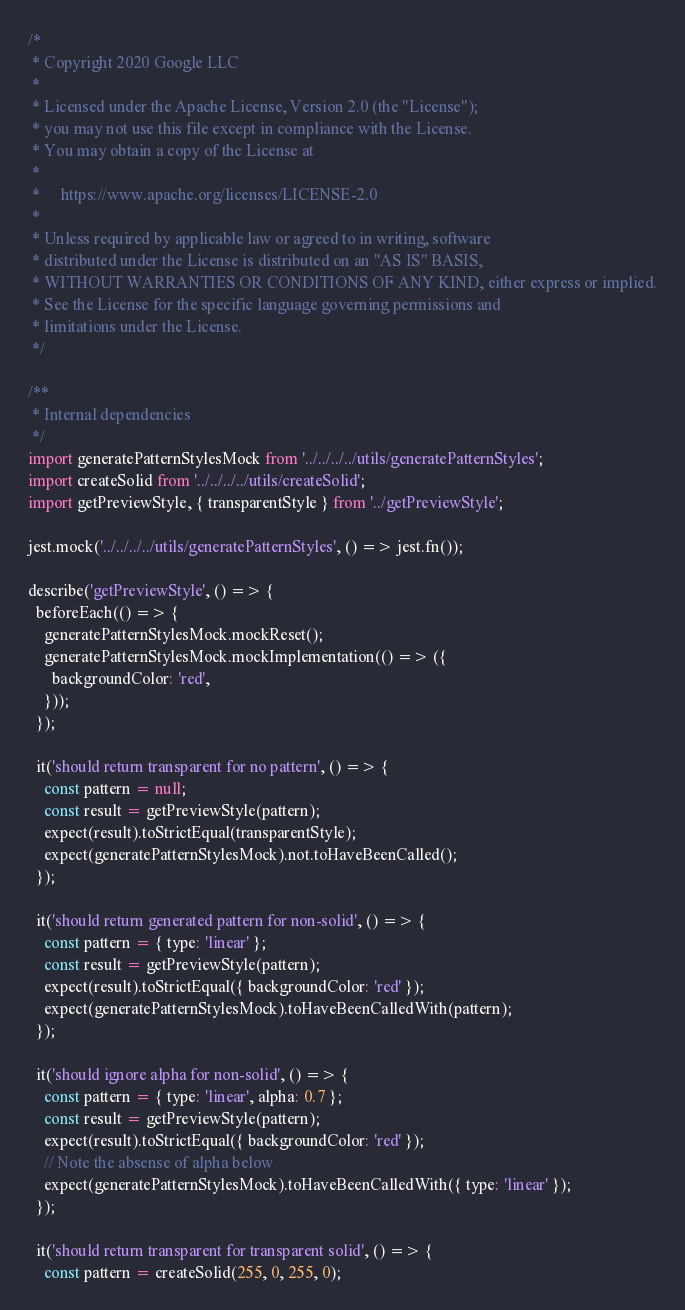<code> <loc_0><loc_0><loc_500><loc_500><_JavaScript_>/*
 * Copyright 2020 Google LLC
 *
 * Licensed under the Apache License, Version 2.0 (the "License");
 * you may not use this file except in compliance with the License.
 * You may obtain a copy of the License at
 *
 *     https://www.apache.org/licenses/LICENSE-2.0
 *
 * Unless required by applicable law or agreed to in writing, software
 * distributed under the License is distributed on an "AS IS" BASIS,
 * WITHOUT WARRANTIES OR CONDITIONS OF ANY KIND, either express or implied.
 * See the License for the specific language governing permissions and
 * limitations under the License.
 */

/**
 * Internal dependencies
 */
import generatePatternStylesMock from '../../../../utils/generatePatternStyles';
import createSolid from '../../../../utils/createSolid';
import getPreviewStyle, { transparentStyle } from '../getPreviewStyle';

jest.mock('../../../../utils/generatePatternStyles', () => jest.fn());

describe('getPreviewStyle', () => {
  beforeEach(() => {
    generatePatternStylesMock.mockReset();
    generatePatternStylesMock.mockImplementation(() => ({
      backgroundColor: 'red',
    }));
  });

  it('should return transparent for no pattern', () => {
    const pattern = null;
    const result = getPreviewStyle(pattern);
    expect(result).toStrictEqual(transparentStyle);
    expect(generatePatternStylesMock).not.toHaveBeenCalled();
  });

  it('should return generated pattern for non-solid', () => {
    const pattern = { type: 'linear' };
    const result = getPreviewStyle(pattern);
    expect(result).toStrictEqual({ backgroundColor: 'red' });
    expect(generatePatternStylesMock).toHaveBeenCalledWith(pattern);
  });

  it('should ignore alpha for non-solid', () => {
    const pattern = { type: 'linear', alpha: 0.7 };
    const result = getPreviewStyle(pattern);
    expect(result).toStrictEqual({ backgroundColor: 'red' });
    // Note the absense of alpha below
    expect(generatePatternStylesMock).toHaveBeenCalledWith({ type: 'linear' });
  });

  it('should return transparent for transparent solid', () => {
    const pattern = createSolid(255, 0, 255, 0);</code> 